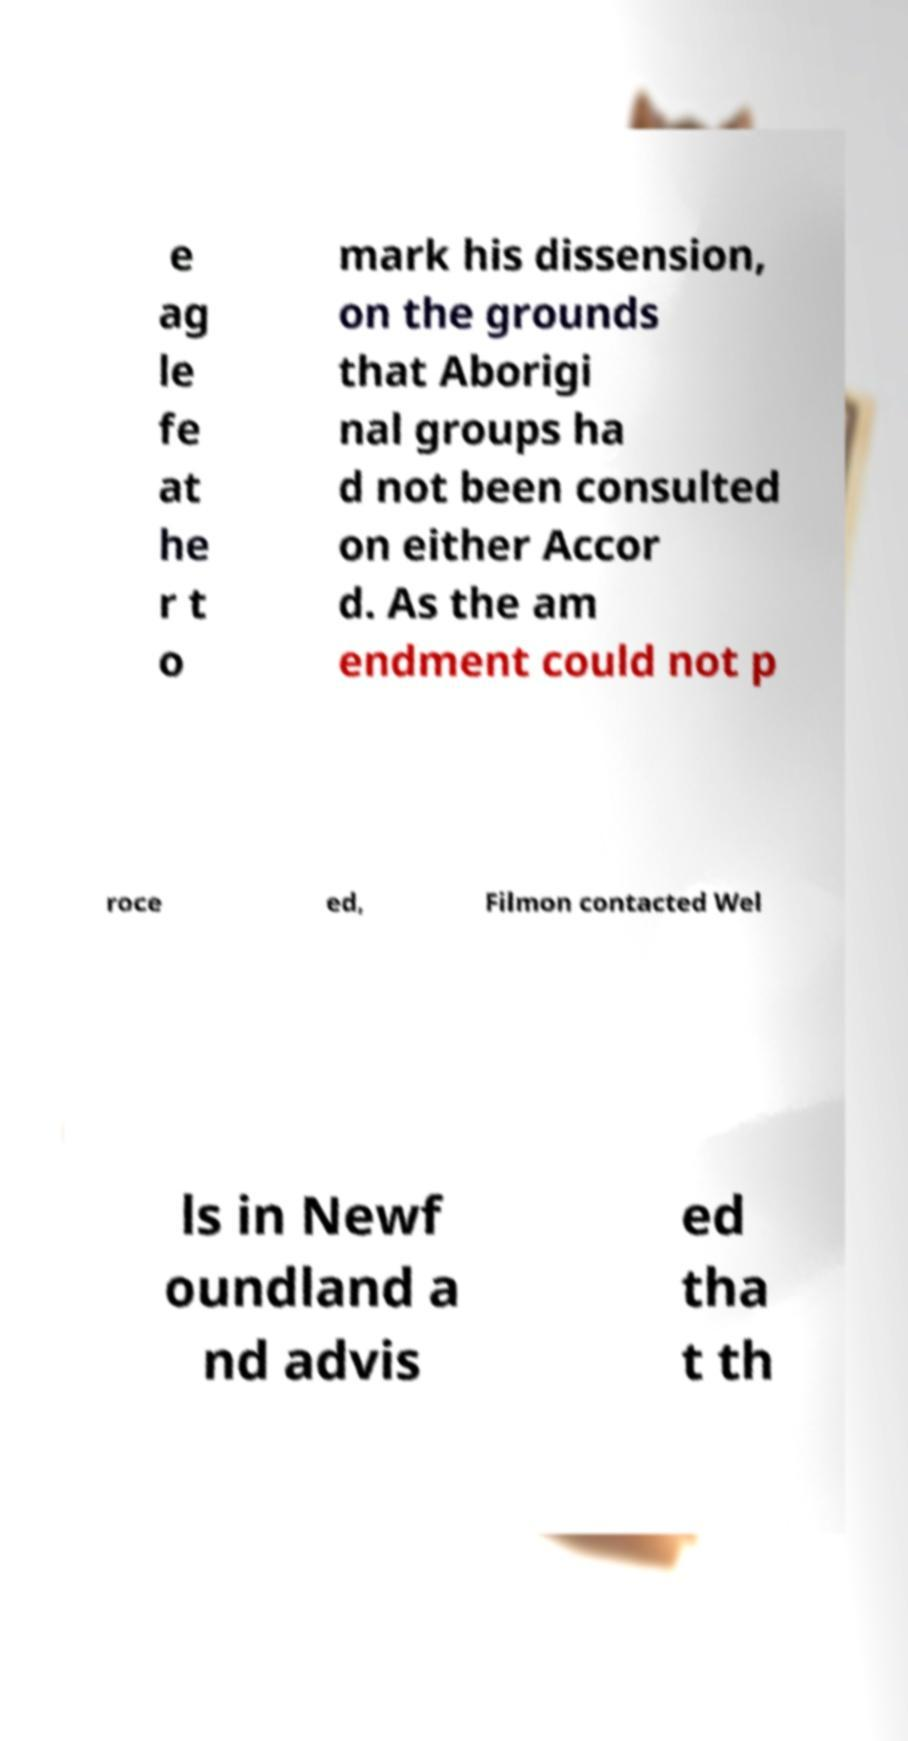I need the written content from this picture converted into text. Can you do that? e ag le fe at he r t o mark his dissension, on the grounds that Aborigi nal groups ha d not been consulted on either Accor d. As the am endment could not p roce ed, Filmon contacted Wel ls in Newf oundland a nd advis ed tha t th 